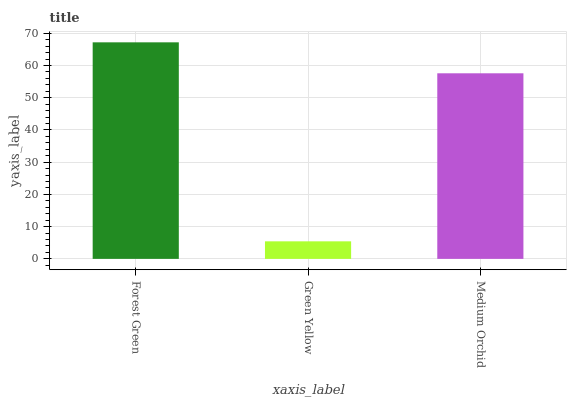Is Green Yellow the minimum?
Answer yes or no. Yes. Is Forest Green the maximum?
Answer yes or no. Yes. Is Medium Orchid the minimum?
Answer yes or no. No. Is Medium Orchid the maximum?
Answer yes or no. No. Is Medium Orchid greater than Green Yellow?
Answer yes or no. Yes. Is Green Yellow less than Medium Orchid?
Answer yes or no. Yes. Is Green Yellow greater than Medium Orchid?
Answer yes or no. No. Is Medium Orchid less than Green Yellow?
Answer yes or no. No. Is Medium Orchid the high median?
Answer yes or no. Yes. Is Medium Orchid the low median?
Answer yes or no. Yes. Is Green Yellow the high median?
Answer yes or no. No. Is Green Yellow the low median?
Answer yes or no. No. 